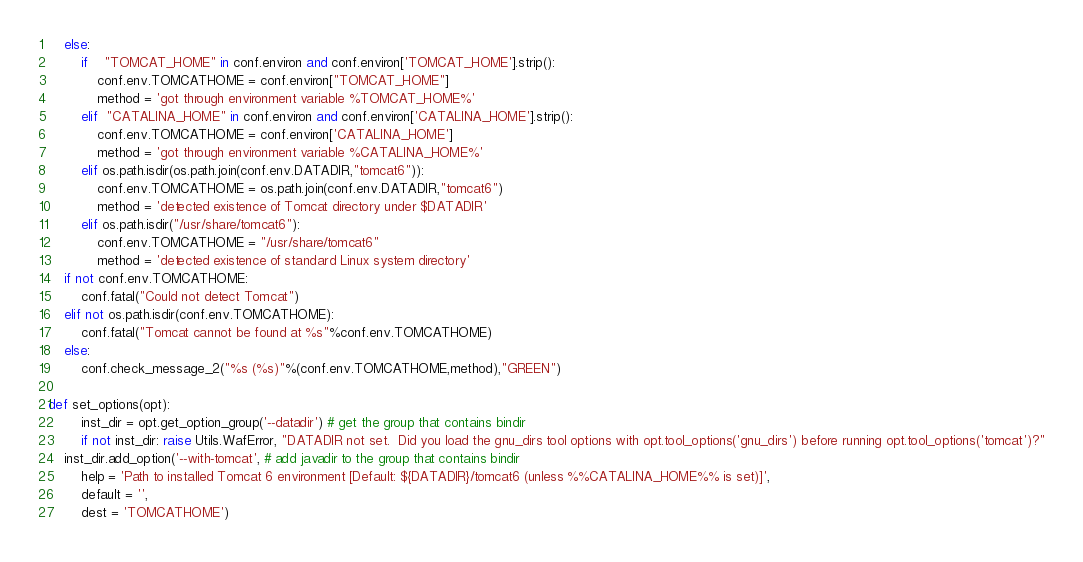<code> <loc_0><loc_0><loc_500><loc_500><_Python_>	else:
		if    "TOMCAT_HOME" in conf.environ and conf.environ['TOMCAT_HOME'].strip():
			conf.env.TOMCATHOME = conf.environ["TOMCAT_HOME"]
			method = 'got through environment variable %TOMCAT_HOME%'
		elif  "CATALINA_HOME" in conf.environ and conf.environ['CATALINA_HOME'].strip():
			conf.env.TOMCATHOME = conf.environ['CATALINA_HOME']
			method = 'got through environment variable %CATALINA_HOME%'
		elif os.path.isdir(os.path.join(conf.env.DATADIR,"tomcat6")):
			conf.env.TOMCATHOME = os.path.join(conf.env.DATADIR,"tomcat6")
			method = 'detected existence of Tomcat directory under $DATADIR'
		elif os.path.isdir("/usr/share/tomcat6"):
			conf.env.TOMCATHOME = "/usr/share/tomcat6"
			method = 'detected existence of standard Linux system directory'
	if not conf.env.TOMCATHOME:
		conf.fatal("Could not detect Tomcat")
	elif not os.path.isdir(conf.env.TOMCATHOME):
		conf.fatal("Tomcat cannot be found at %s"%conf.env.TOMCATHOME)
	else:
		conf.check_message_2("%s (%s)"%(conf.env.TOMCATHOME,method),"GREEN")

def set_options(opt):
        inst_dir = opt.get_option_group('--datadir') # get the group that contains bindir
        if not inst_dir: raise Utils.WafError, "DATADIR not set.  Did you load the gnu_dirs tool options with opt.tool_options('gnu_dirs') before running opt.tool_options('tomcat')?"
	inst_dir.add_option('--with-tomcat', # add javadir to the group that contains bindir
		help = 'Path to installed Tomcat 6 environment [Default: ${DATADIR}/tomcat6 (unless %%CATALINA_HOME%% is set)]',
		default = '',
		dest = 'TOMCATHOME')</code> 